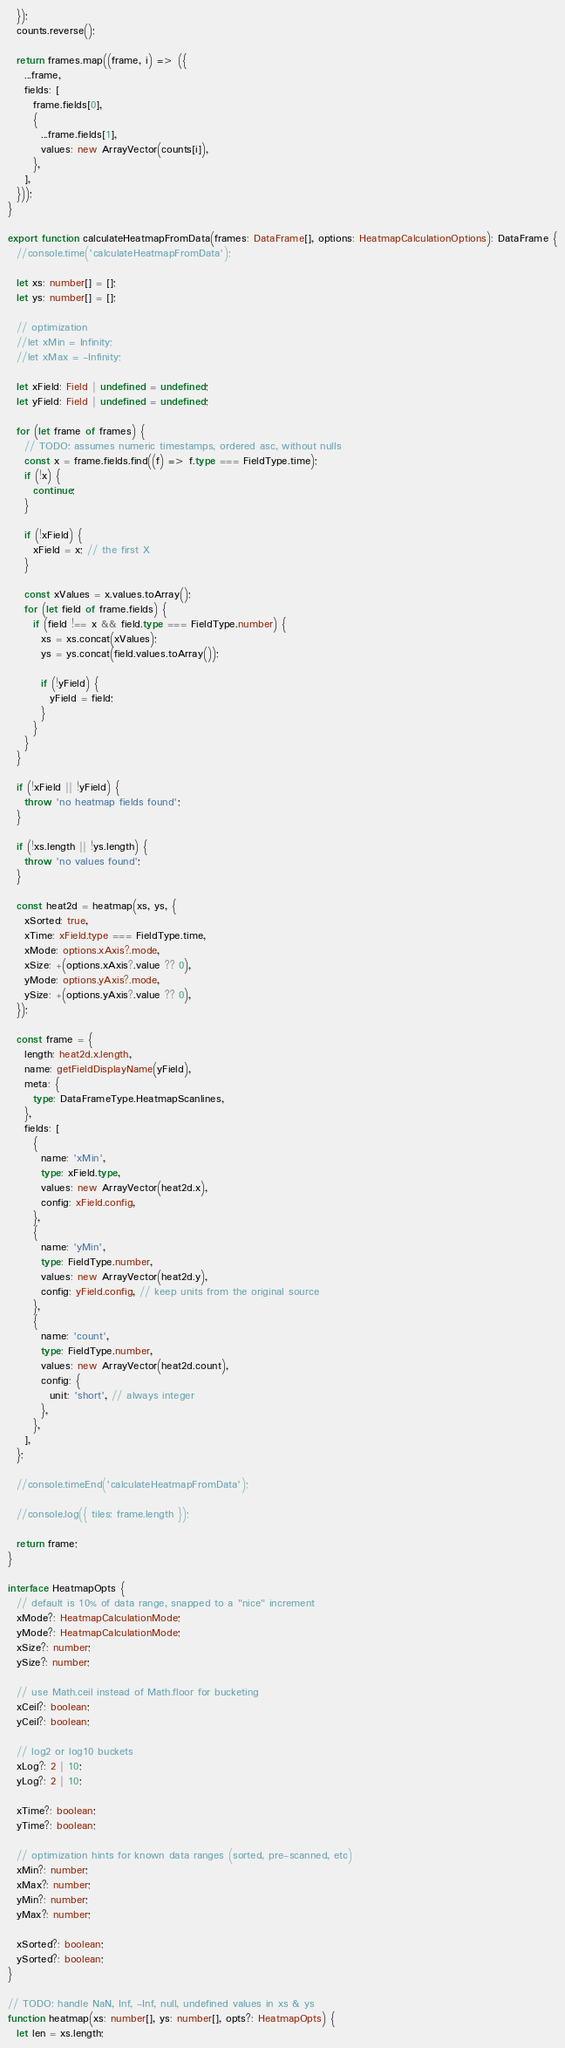Convert code to text. <code><loc_0><loc_0><loc_500><loc_500><_TypeScript_>  });
  counts.reverse();

  return frames.map((frame, i) => ({
    ...frame,
    fields: [
      frame.fields[0],
      {
        ...frame.fields[1],
        values: new ArrayVector(counts[i]),
      },
    ],
  }));
}

export function calculateHeatmapFromData(frames: DataFrame[], options: HeatmapCalculationOptions): DataFrame {
  //console.time('calculateHeatmapFromData');

  let xs: number[] = [];
  let ys: number[] = [];

  // optimization
  //let xMin = Infinity;
  //let xMax = -Infinity;

  let xField: Field | undefined = undefined;
  let yField: Field | undefined = undefined;

  for (let frame of frames) {
    // TODO: assumes numeric timestamps, ordered asc, without nulls
    const x = frame.fields.find((f) => f.type === FieldType.time);
    if (!x) {
      continue;
    }

    if (!xField) {
      xField = x; // the first X
    }

    const xValues = x.values.toArray();
    for (let field of frame.fields) {
      if (field !== x && field.type === FieldType.number) {
        xs = xs.concat(xValues);
        ys = ys.concat(field.values.toArray());

        if (!yField) {
          yField = field;
        }
      }
    }
  }

  if (!xField || !yField) {
    throw 'no heatmap fields found';
  }

  if (!xs.length || !ys.length) {
    throw 'no values found';
  }

  const heat2d = heatmap(xs, ys, {
    xSorted: true,
    xTime: xField.type === FieldType.time,
    xMode: options.xAxis?.mode,
    xSize: +(options.xAxis?.value ?? 0),
    yMode: options.yAxis?.mode,
    ySize: +(options.yAxis?.value ?? 0),
  });

  const frame = {
    length: heat2d.x.length,
    name: getFieldDisplayName(yField),
    meta: {
      type: DataFrameType.HeatmapScanlines,
    },
    fields: [
      {
        name: 'xMin',
        type: xField.type,
        values: new ArrayVector(heat2d.x),
        config: xField.config,
      },
      {
        name: 'yMin',
        type: FieldType.number,
        values: new ArrayVector(heat2d.y),
        config: yField.config, // keep units from the original source
      },
      {
        name: 'count',
        type: FieldType.number,
        values: new ArrayVector(heat2d.count),
        config: {
          unit: 'short', // always integer
        },
      },
    ],
  };

  //console.timeEnd('calculateHeatmapFromData');

  //console.log({ tiles: frame.length });

  return frame;
}

interface HeatmapOpts {
  // default is 10% of data range, snapped to a "nice" increment
  xMode?: HeatmapCalculationMode;
  yMode?: HeatmapCalculationMode;
  xSize?: number;
  ySize?: number;

  // use Math.ceil instead of Math.floor for bucketing
  xCeil?: boolean;
  yCeil?: boolean;

  // log2 or log10 buckets
  xLog?: 2 | 10;
  yLog?: 2 | 10;

  xTime?: boolean;
  yTime?: boolean;

  // optimization hints for known data ranges (sorted, pre-scanned, etc)
  xMin?: number;
  xMax?: number;
  yMin?: number;
  yMax?: number;

  xSorted?: boolean;
  ySorted?: boolean;
}

// TODO: handle NaN, Inf, -Inf, null, undefined values in xs & ys
function heatmap(xs: number[], ys: number[], opts?: HeatmapOpts) {
  let len = xs.length;
</code> 